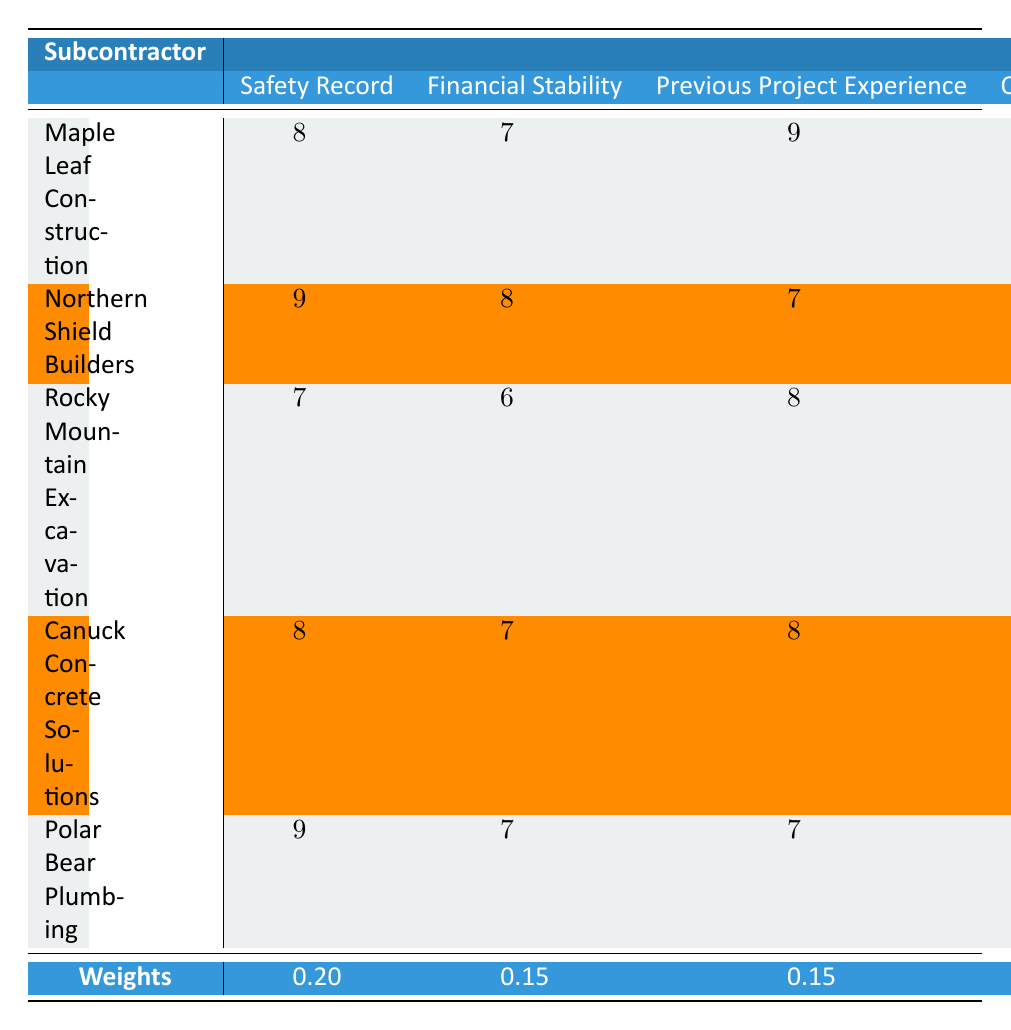What is the safety record score of Polar Bear Plumbing? The safety record score for Polar Bear Plumbing is found in the "Safety Record" column, corresponding to the row for Polar Bear Plumbing. It is 9.
Answer: 9 Which subcontractor has the highest score in Quality of Work? By comparing the scores in the "Quality of Work" column, Canuck Concrete Solutions has the highest score of 9.
Answer: Canuck Concrete Solutions What is the average score of Maple Leaf Construction across all criteria? The scores for Maple Leaf Construction are 8, 7, 9, 8, 7, 9, 6, and 8. The sum is 8 + 7 + 9 + 8 + 7 + 9 + 6 + 8 = 62. Since there are 8 criteria, the average is 62 / 8 = 7.75.
Answer: 7.75 Is Northern Shield Builders' Financial Stability score greater than its Price score? The Financial Stability score of Northern Shield Builders is 8 and the Price score is 7. Since 8 is greater than 7, the answer is yes.
Answer: Yes What is the difference between the highest and lowest score for Rocky Mountain Excavation? For Rocky Mountain Excavation, the scores are 7, 6, 8, 7, 9, 8, 8, and 7. The highest score is 9, and the lowest is 6. The difference is 9 - 6 = 3.
Answer: 3 How many subcontractors have a Local Knowledge score of 9 or higher? Maple Leaf Construction and Polar Bear Plumbing both have a Local Knowledge score of 9, which totals 2 subcontractors meeting this criterion.
Answer: 2 What is the total weighted score for Canuck Concrete Solutions? We first multiply each score for Canuck Concrete Solutions by its corresponding weight: (8 * 0.20) + (7 * 0.15) + (8 * 0.15) + (9 * 0.15) + (8 * 0.10) + (8 * 0.05) + (7 * 0.10) + (9 * 0.10). This results in (1.6 + 1.05 + 1.2 + 1.35 + 0.8 + 0.4 + 0.7 + 0.9) = 7.1.
Answer: 7.1 Which subcontractor shows the best Schedule Adherence compared to others? By examining the "Schedule Adherence" column, Canuck Concrete Solutions has the highest score of 9, indicating it performs the best in this regard.
Answer: Canuck Concrete Solutions How does the Price score of Rocky Mountain Excavation compare to the average price score of all subcontractors? The Price score of Rocky Mountain Excavation is 8. The average price score is (6 + 7 + 8 + 7 + 8) / 5 = 7.2. Since 8 is greater than 7.2, this means Rocky Mountain Excavation's score is above average.
Answer: Above average 